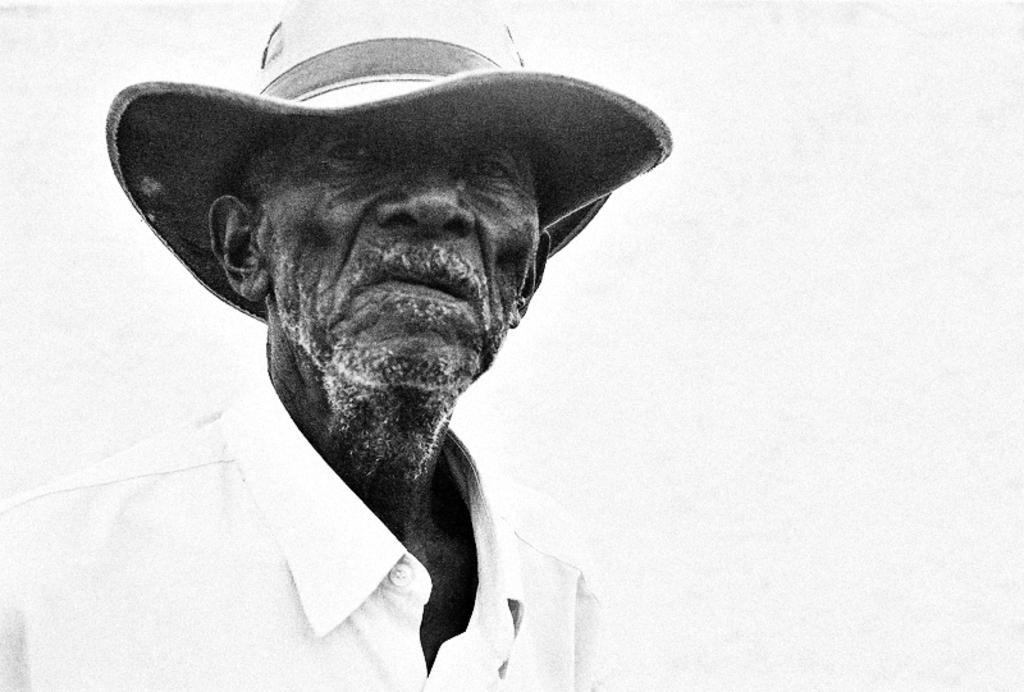What is the main subject of the image? There is a person standing in the image. What is the person wearing on their head? The person is wearing a cap. What can be seen in the background of the image? There is a wall visible in the background of the image. What type of guitar is the person playing in the image? There is no guitar present in the image; the person is only wearing a cap and standing near a wall. What is the strength of the zephyr blowing in the image? There is no mention of a zephyr or any wind in the image; it only features a person standing and wearing a cap. 